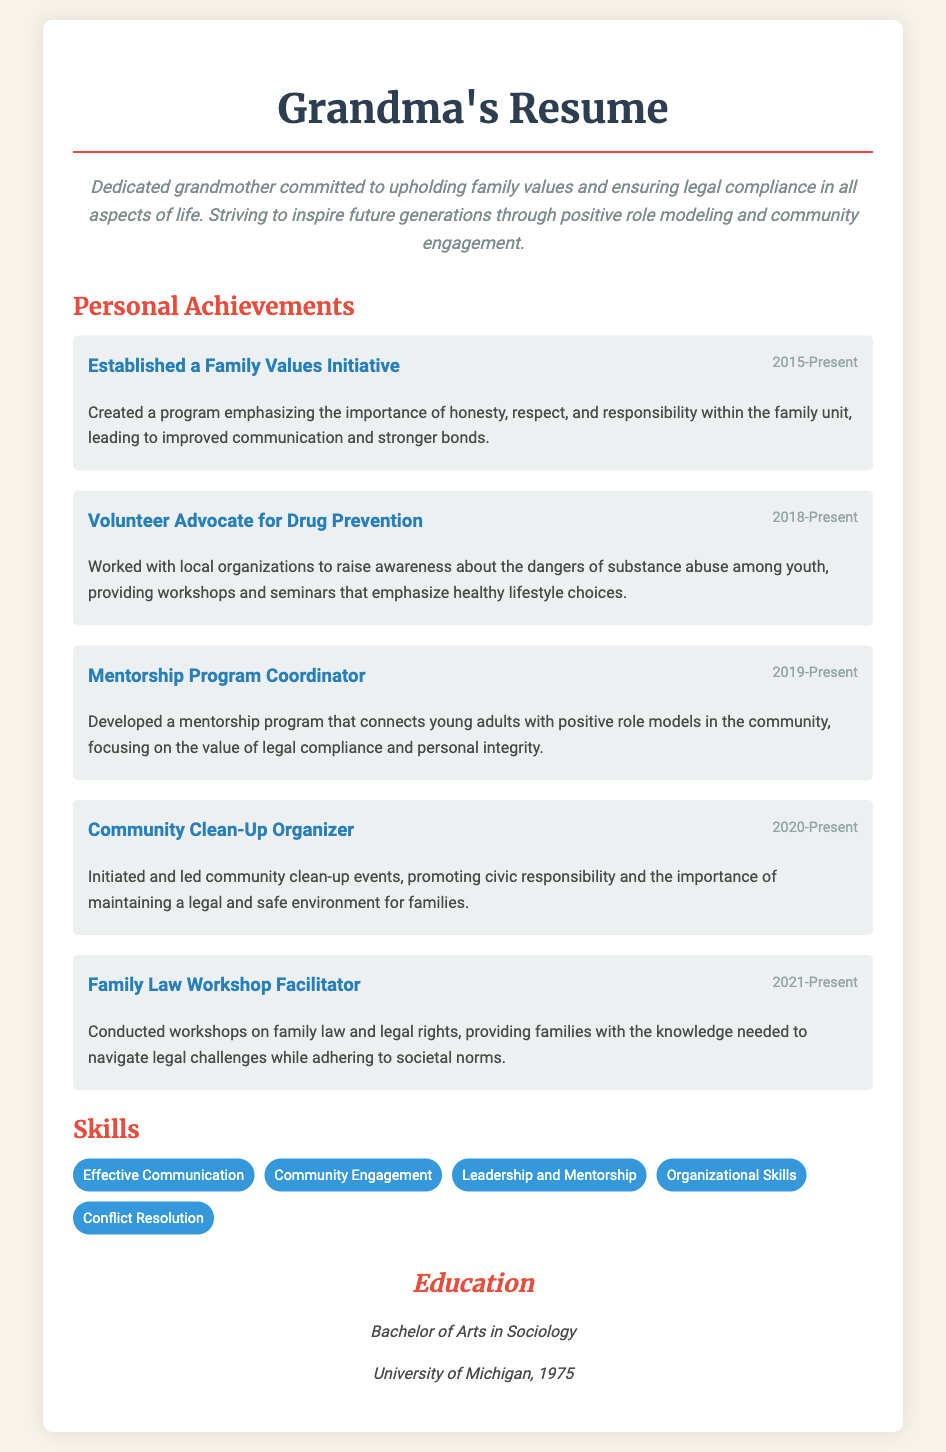What is the title of the document? The title of the document is displayed prominently at the top, indicating the focus of the resume.
Answer: Grandma's Resume - Family Values Champion What is the objective stated in the resume? The objective outlines the main goals and commitment of the individual, providing insight into their values and dedication.
Answer: Dedicated grandmother committed to upholding family values and ensuring legal compliance in all aspects of life In which year did the Family Values Initiative start? The date is included with the achievement details, marking the beginning of this initiative in the document.
Answer: 2015 What role does the volunteer advocate hold? The specific role is mentioned as part of their achievements, showing their involvement in promoting substance abuse prevention.
Answer: Volunteer Advocate for Drug Prevention How many personal achievements are listed in the resume? The total number of achievements can be counted from the separate sections in the document.
Answer: Five What program did the individual develop to connect young adults with role models? This program's title is found in the achievements section, focusing on mentorship.
Answer: Mentorship Program Coordinator What key skills are mentioned in the document? The skills are listed, reflecting the individual's abilities and strengths related to their experiences.
Answer: Effective Communication, Community Engagement, Leadership and Mentorship, Organizational Skills, Conflict Resolution What is the highest level of education attained, according to the document? The education section specifies the highest degree completed by the individual.
Answer: Bachelor of Arts in Sociology In what year did the individual graduate from university? The graduation year is provided in the educational background, marking the completion of their degree.
Answer: 1975 